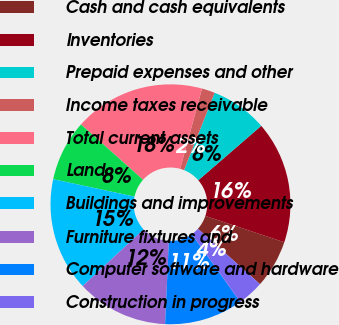Convert chart. <chart><loc_0><loc_0><loc_500><loc_500><pie_chart><fcel>Cash and cash equivalents<fcel>Inventories<fcel>Prepaid expenses and other<fcel>Income taxes receivable<fcel>Total current assets<fcel>Land<fcel>Buildings and improvements<fcel>Furniture fixtures and<fcel>Computer software and hardware<fcel>Construction in progress<nl><fcel>6.47%<fcel>16.47%<fcel>7.65%<fcel>1.77%<fcel>17.64%<fcel>8.24%<fcel>15.29%<fcel>12.35%<fcel>10.59%<fcel>3.53%<nl></chart> 